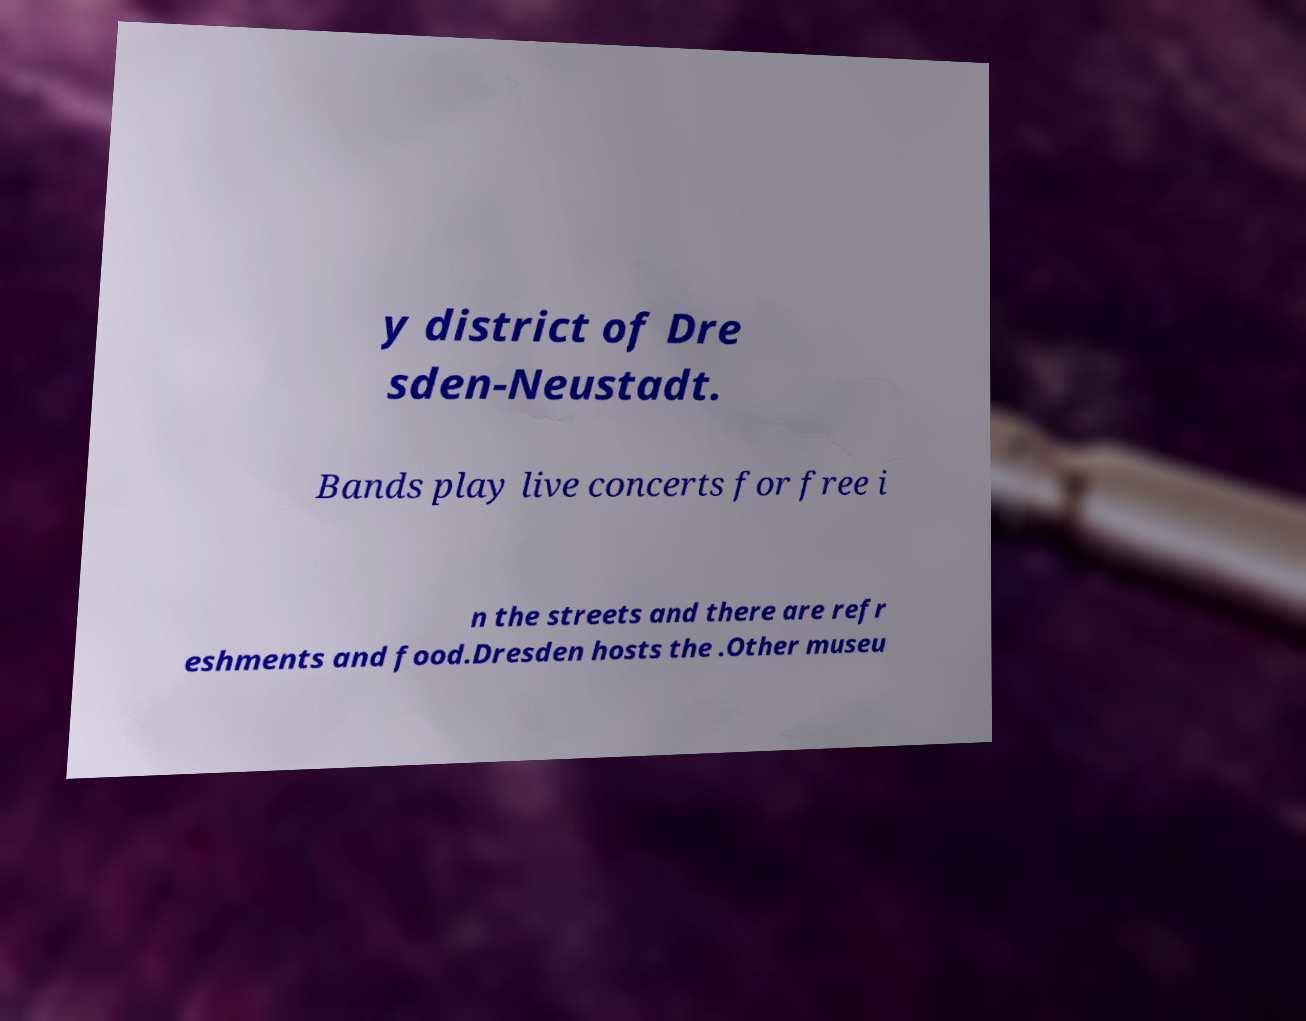Could you assist in decoding the text presented in this image and type it out clearly? y district of Dre sden-Neustadt. Bands play live concerts for free i n the streets and there are refr eshments and food.Dresden hosts the .Other museu 